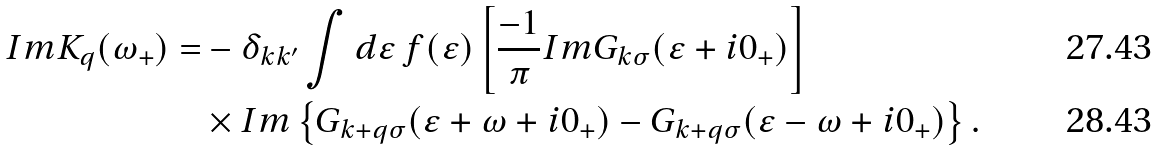Convert formula to latex. <formula><loc_0><loc_0><loc_500><loc_500>I m K _ { q } ( \omega _ { + } ) = & - \delta _ { { k } { k ^ { \prime } } } \int d \varepsilon \ f ( \varepsilon ) \left [ \frac { - 1 } { \pi } I m G _ { { k } \sigma } ( \varepsilon + i 0 _ { + } ) \right ] \\ & \times I m \left \{ G _ { { k } + { q } \sigma } ( \varepsilon + \omega + i 0 _ { + } ) - G _ { { k } + { q } \sigma } ( \varepsilon - \omega + i 0 _ { + } ) \right \} .</formula> 